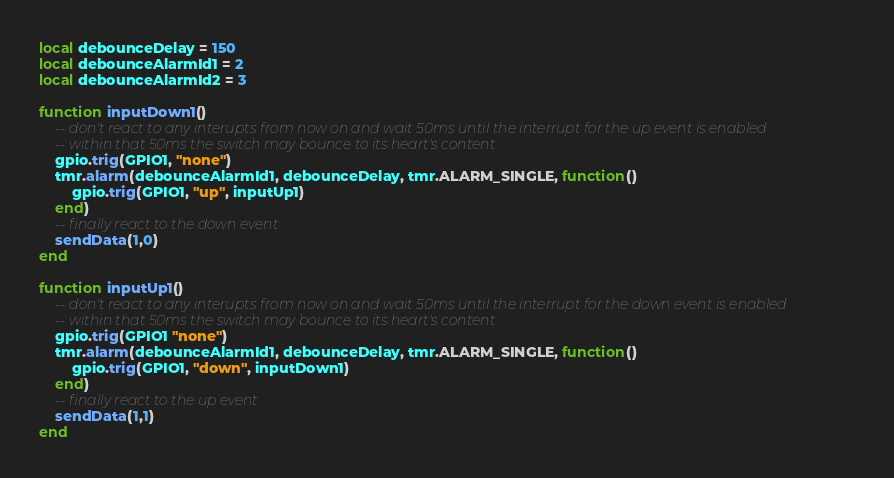<code> <loc_0><loc_0><loc_500><loc_500><_Lua_>local debounceDelay = 150
local debounceAlarmId1 = 2
local debounceAlarmId2 = 3

function inputDown1()
    -- don't react to any interupts from now on and wait 50ms until the interrupt for the up event is enabled
    -- within that 50ms the switch may bounce to its heart's content
    gpio.trig(GPIO1, "none")
    tmr.alarm(debounceAlarmId1, debounceDelay, tmr.ALARM_SINGLE, function()
        gpio.trig(GPIO1, "up", inputUp1)
    end)
    -- finally react to the down event
    sendData(1,0)
end

function inputUp1()
    -- don't react to any interupts from now on and wait 50ms until the interrupt for the down event is enabled
    -- within that 50ms the switch may bounce to its heart's content
    gpio.trig(GPIO1 "none")
    tmr.alarm(debounceAlarmId1, debounceDelay, tmr.ALARM_SINGLE, function()
        gpio.trig(GPIO1, "down", inputDown1)
    end)
    -- finally react to the up event
    sendData(1,1)
end
</code> 